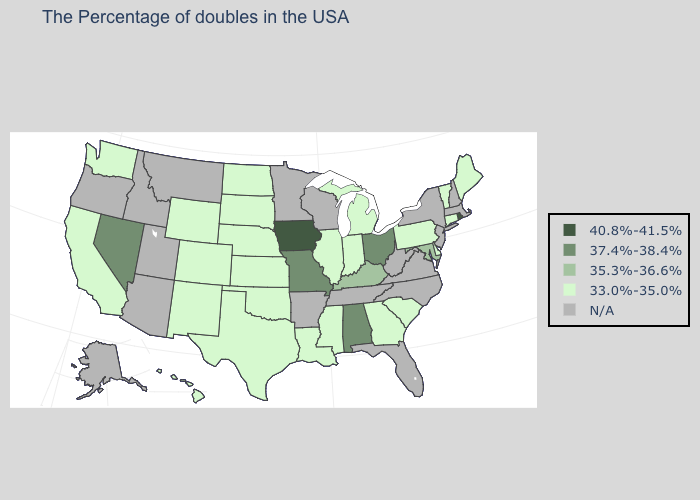Name the states that have a value in the range 33.0%-35.0%?
Short answer required. Maine, Vermont, Connecticut, Delaware, Pennsylvania, South Carolina, Georgia, Michigan, Indiana, Illinois, Mississippi, Louisiana, Kansas, Nebraska, Oklahoma, Texas, South Dakota, North Dakota, Wyoming, Colorado, New Mexico, California, Washington, Hawaii. Does the first symbol in the legend represent the smallest category?
Concise answer only. No. Does the first symbol in the legend represent the smallest category?
Be succinct. No. What is the highest value in the West ?
Write a very short answer. 37.4%-38.4%. Among the states that border Pennsylvania , does Delaware have the lowest value?
Give a very brief answer. Yes. Name the states that have a value in the range 37.4%-38.4%?
Concise answer only. Ohio, Alabama, Missouri, Nevada. What is the value of Arizona?
Write a very short answer. N/A. What is the lowest value in the West?
Keep it brief. 33.0%-35.0%. Name the states that have a value in the range 37.4%-38.4%?
Keep it brief. Ohio, Alabama, Missouri, Nevada. What is the highest value in the Northeast ?
Keep it brief. 40.8%-41.5%. What is the lowest value in states that border New Mexico?
Answer briefly. 33.0%-35.0%. What is the lowest value in states that border Montana?
Be succinct. 33.0%-35.0%. What is the highest value in states that border Minnesota?
Keep it brief. 40.8%-41.5%. 